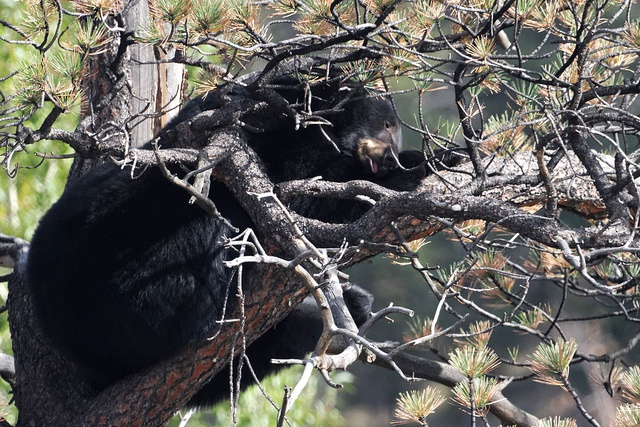Describe the objects in this image and their specific colors. I can see a bear in lightgreen, black, gray, and darkgray tones in this image. 